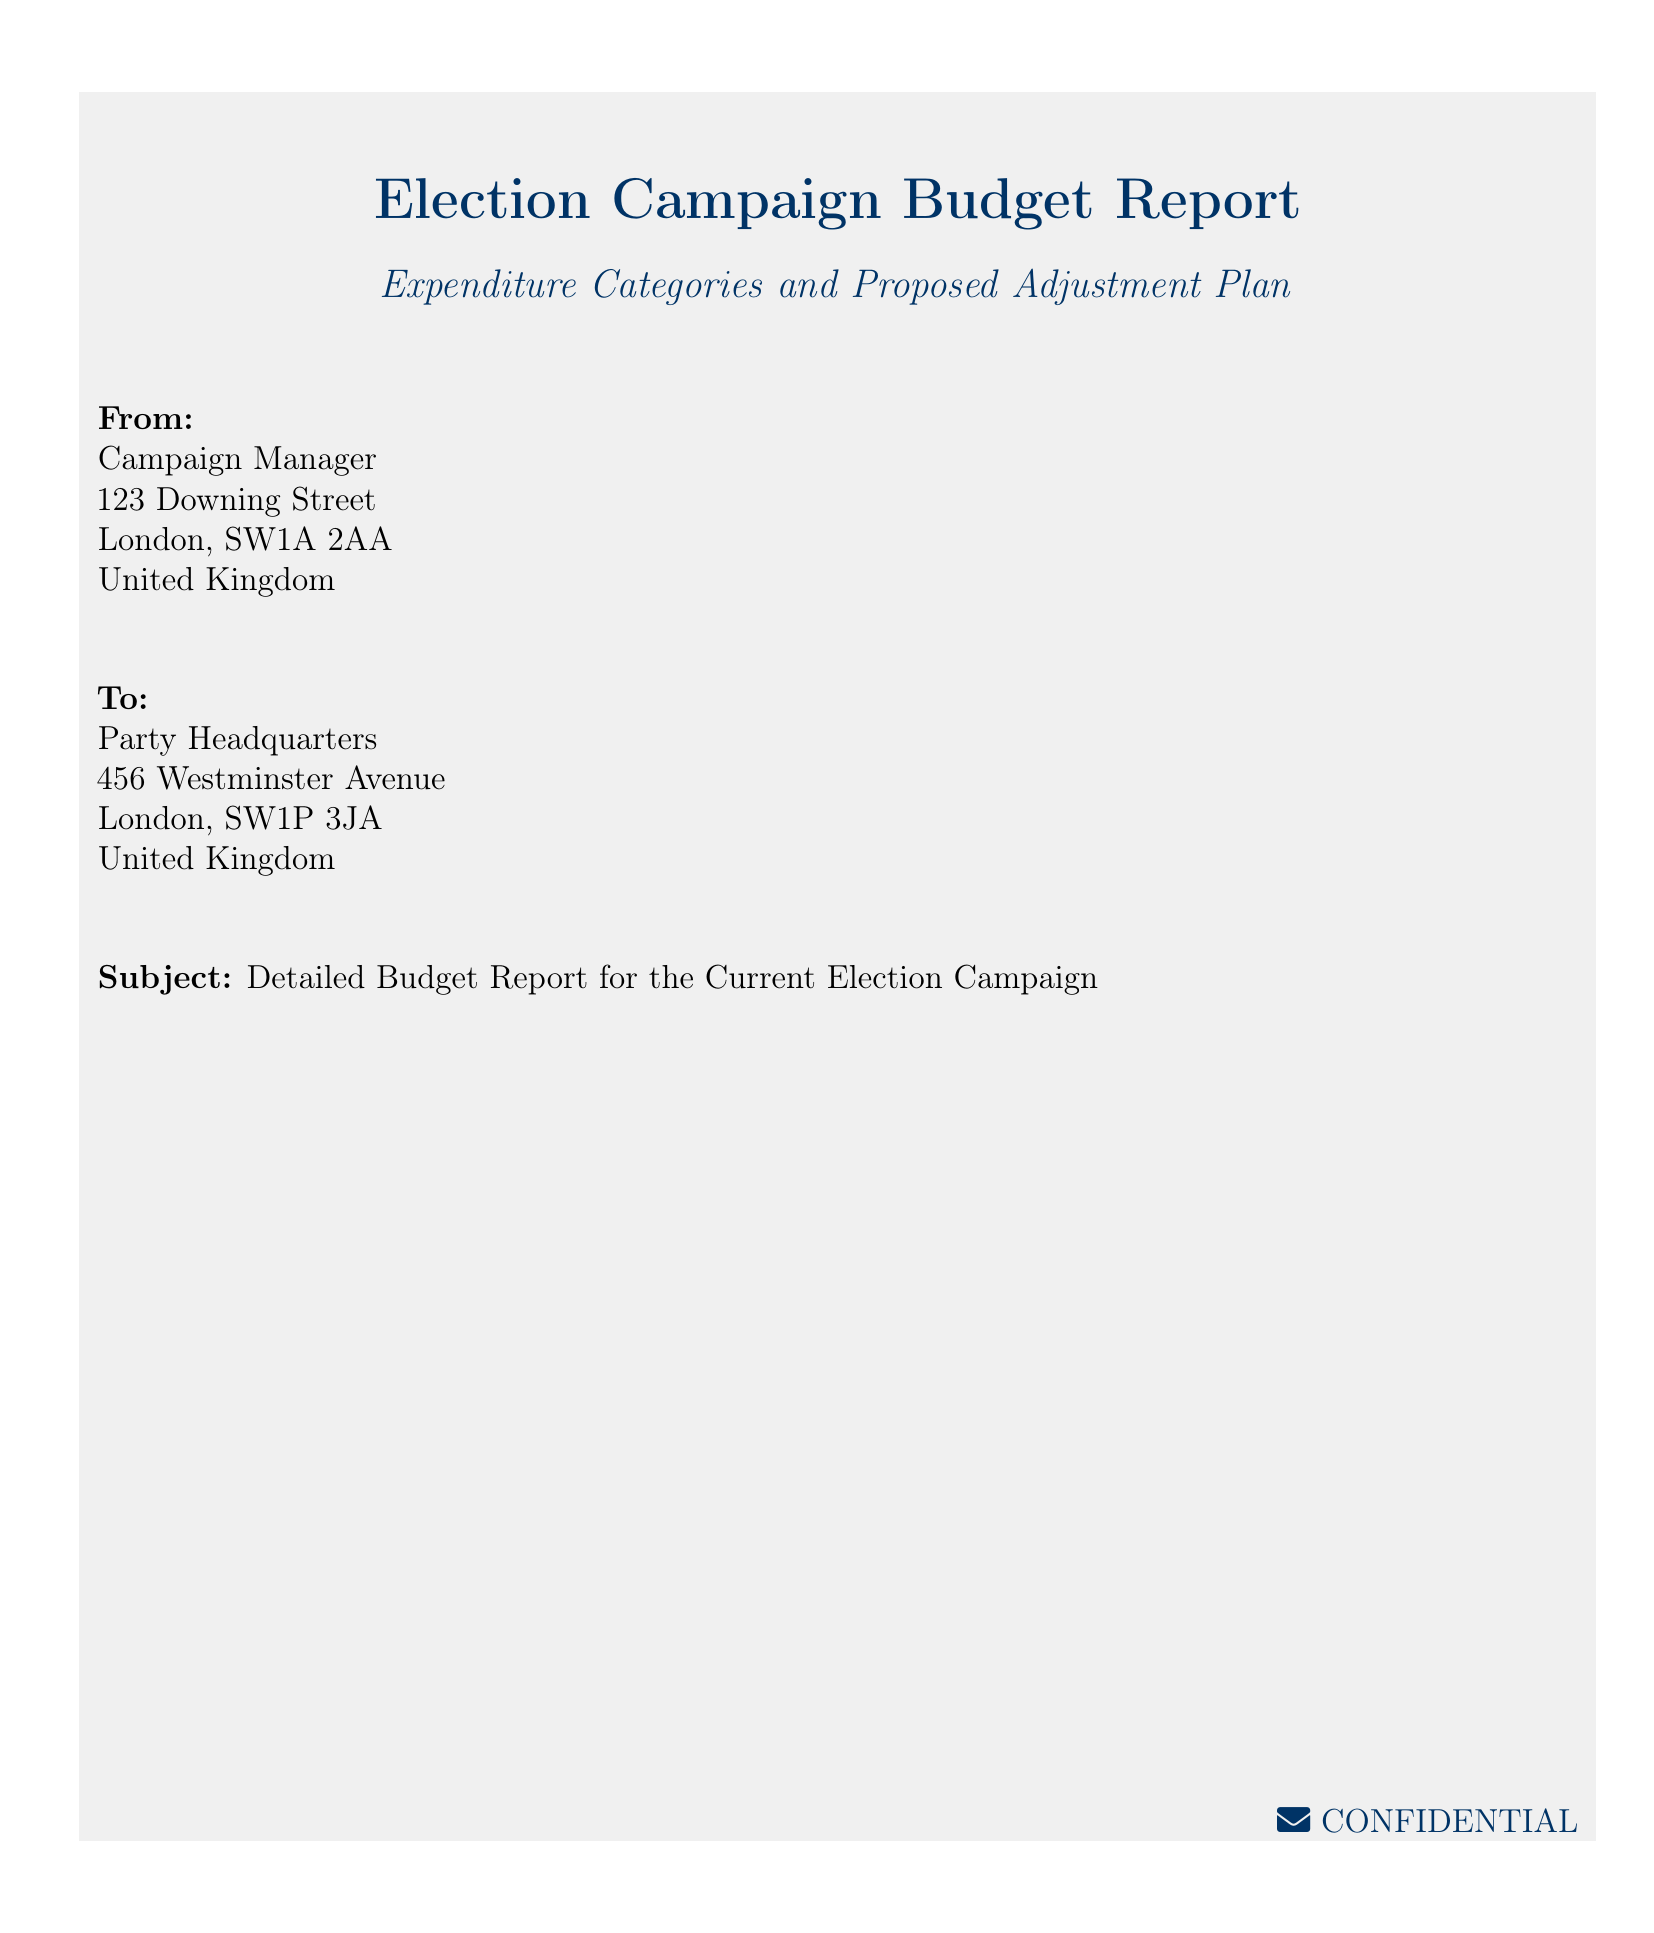What is the title of the report? The title of the report is specified in the header of the document.
Answer: Election Campaign Budget Report Who is the sender of the document? The sender's information can be found under the "From" section in the document.
Answer: Campaign Manager What is the subject of the report? The subject is clearly stated in the document under the "Subject" section.
Answer: Detailed Budget Report for the Current Election Campaign Where is the sender located? The sender's address is indicated in the "From" section of the envelope.
Answer: 123 Downing Street, London, SW1A 2AA, United Kingdom Who is the recipient of the document? The recipient is named in the "To" section of the document.
Answer: Party Headquarters What category of information does the document mainly cover? The document's focus is conveyed by its title and subject details.
Answer: Expenditure Categories and Proposed Adjustment Plan How many entities are mentioned in the document? The document mentions two distinct entities: sender and recipient.
Answer: Two What format is this document presented in? The style and structure of the document classify it as a specific type based on its layout.
Answer: Envelope What color is used for the title in the document? The document specifies the color scheme used for headings and important sections.
Answer: Dark Blue 